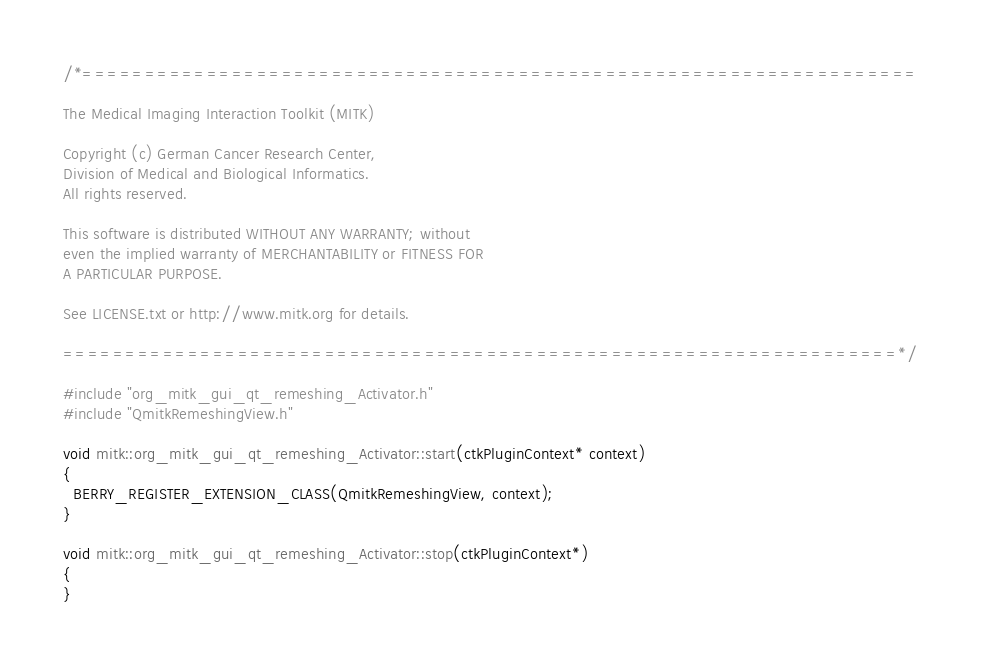<code> <loc_0><loc_0><loc_500><loc_500><_C++_>/*===================================================================

The Medical Imaging Interaction Toolkit (MITK)

Copyright (c) German Cancer Research Center,
Division of Medical and Biological Informatics.
All rights reserved.

This software is distributed WITHOUT ANY WARRANTY; without
even the implied warranty of MERCHANTABILITY or FITNESS FOR
A PARTICULAR PURPOSE.

See LICENSE.txt or http://www.mitk.org for details.

===================================================================*/

#include "org_mitk_gui_qt_remeshing_Activator.h"
#include "QmitkRemeshingView.h"

void mitk::org_mitk_gui_qt_remeshing_Activator::start(ctkPluginContext* context)
{
  BERRY_REGISTER_EXTENSION_CLASS(QmitkRemeshingView, context);
}

void mitk::org_mitk_gui_qt_remeshing_Activator::stop(ctkPluginContext*)
{
}
</code> 